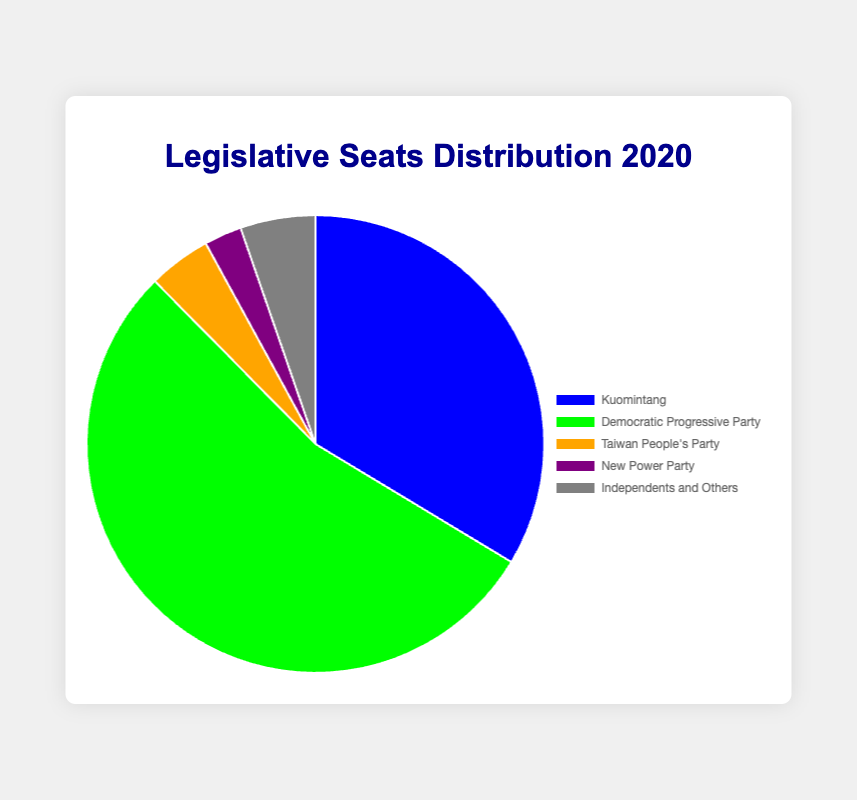What percentage of legislative seats is held by the Kuomintang? The Kuomintang holds 38 seats out of a total of 113 (38+61+5+3+6=113). The percentage is calculated as (38/113)*100.
Answer: 33.63% Which party holds the highest number of seats? By observing the pie chart, the Democratic Progressive Party has the largest portion.
Answer: Democratic Progressive Party How many more seats does the Democratic Progressive Party hold compared to the Kuomintang? The Democratic Progressive Party holds 61 seats, and the Kuomintang holds 38. Subtracting these gives 61 - 38.
Answer: 23 What is the combined total of seats held by minor parties (Taiwan People’s Party, New Power Party, and Independents and Others)? Summing the seats for the Taiwan People's Party (5), New Power Party (3), and Independents and Others (6) gives 5 + 3 + 6.
Answer: 14 Which party is represented by the purple section of the pie chart? The legend shows that the New Power Party is depicted in purple.
Answer: New Power Party Among the parties listed, rank them in descending order based on the number of seats they hold. The order from most seats to least is: Democratic Progressive Party (61), Kuomintang (38), Independents and Others (6), Taiwan People’s Party (5), New Power Party (3).
Answer: Democratic Progressive Party, Kuomintang, Independents and Others, Taiwan People’s Party, New Power Party What is the ratio of seats held by the Kuomintang to seats held by the Taiwan People’s Party? The Kuomintang holds 38 seats, and the Taiwan People’s Party holds 5 seats; hence the ratio is 38 to 5.
Answer: 38:5 If the number of seats for each party were to double, what would be the new total number of seats? Doubling the seats for each party: Kuomintang (38*2=76), Democratic Progressive Party (61*2=122), Taiwan People's Party (5*2=10), New Power Party (3*2=6), Independents and Others (6*2=12). Summing these gives 76 + 122 + 10 + 6 + 12.
Answer: 226 